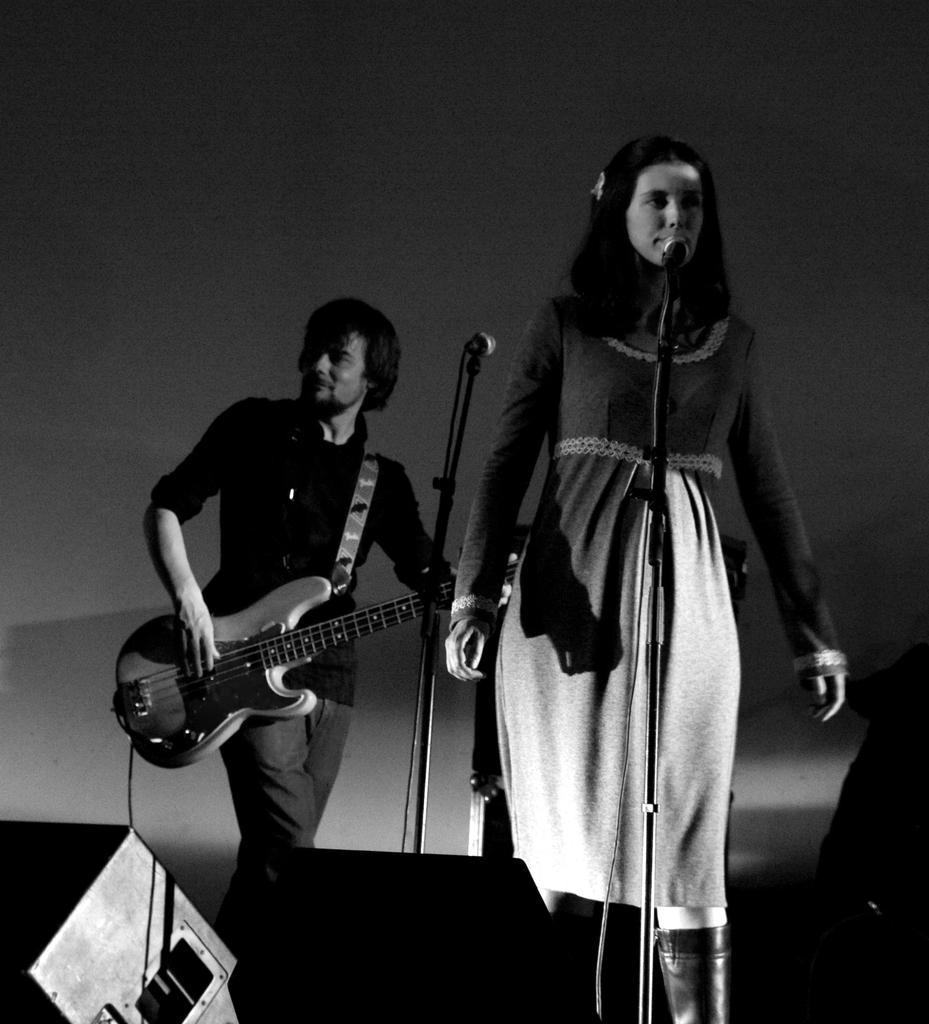In one or two sentences, can you explain what this image depicts? In this picture we can see man standing and holding guitar in his hand and playing it and in front woman singing on mic they both are on stage and this is black and white picture. 